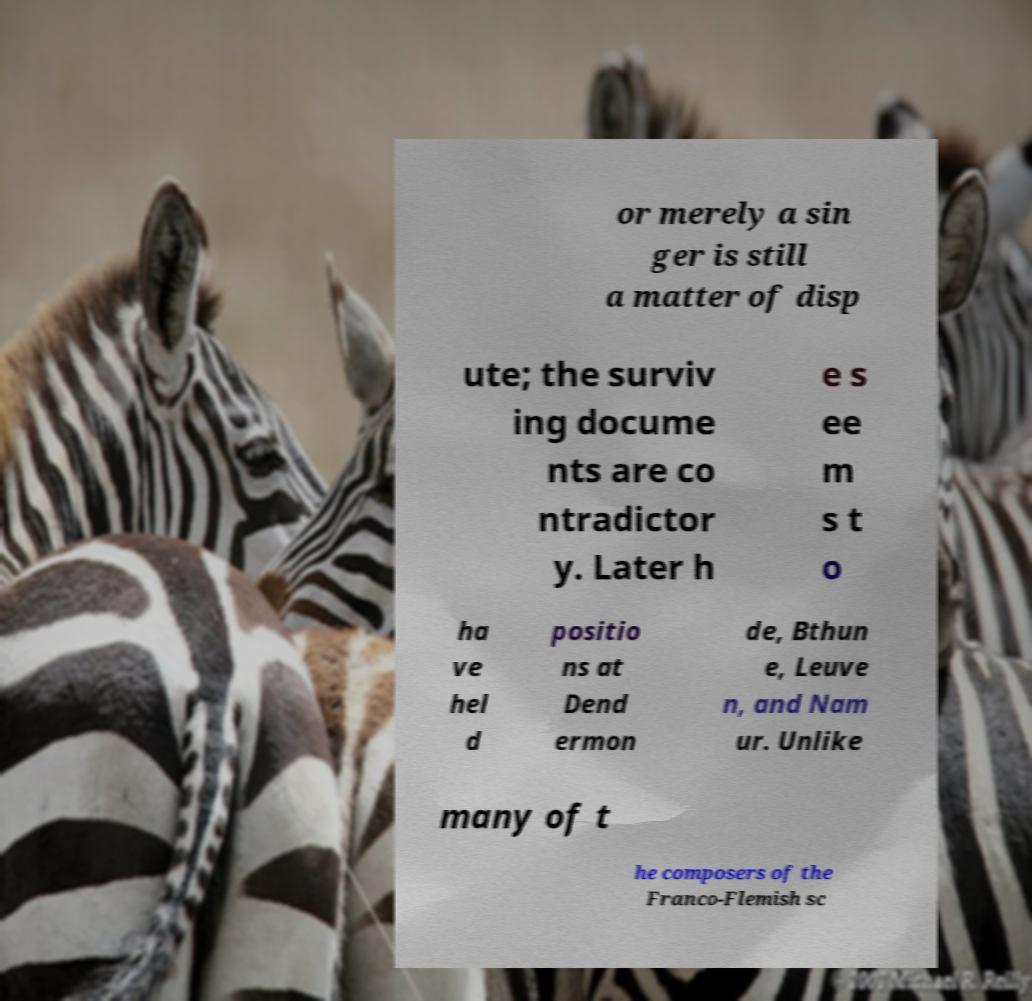For documentation purposes, I need the text within this image transcribed. Could you provide that? or merely a sin ger is still a matter of disp ute; the surviv ing docume nts are co ntradictor y. Later h e s ee m s t o ha ve hel d positio ns at Dend ermon de, Bthun e, Leuve n, and Nam ur. Unlike many of t he composers of the Franco-Flemish sc 